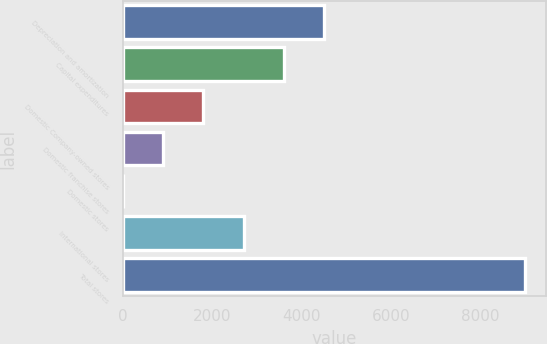<chart> <loc_0><loc_0><loc_500><loc_500><bar_chart><fcel>Depreciation and amortization<fcel>Capital expenditures<fcel>Domestic Company-owned stores<fcel>Domestic franchise stores<fcel>Domestic stores<fcel>International stores<fcel>Total stores<nl><fcel>4499.75<fcel>3599.9<fcel>1800.2<fcel>900.35<fcel>0.5<fcel>2700.05<fcel>8999<nl></chart> 